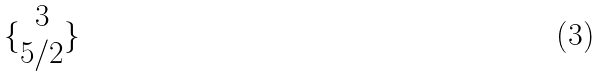<formula> <loc_0><loc_0><loc_500><loc_500>\{ \begin{matrix} 3 \\ 5 / 2 \end{matrix} \}</formula> 